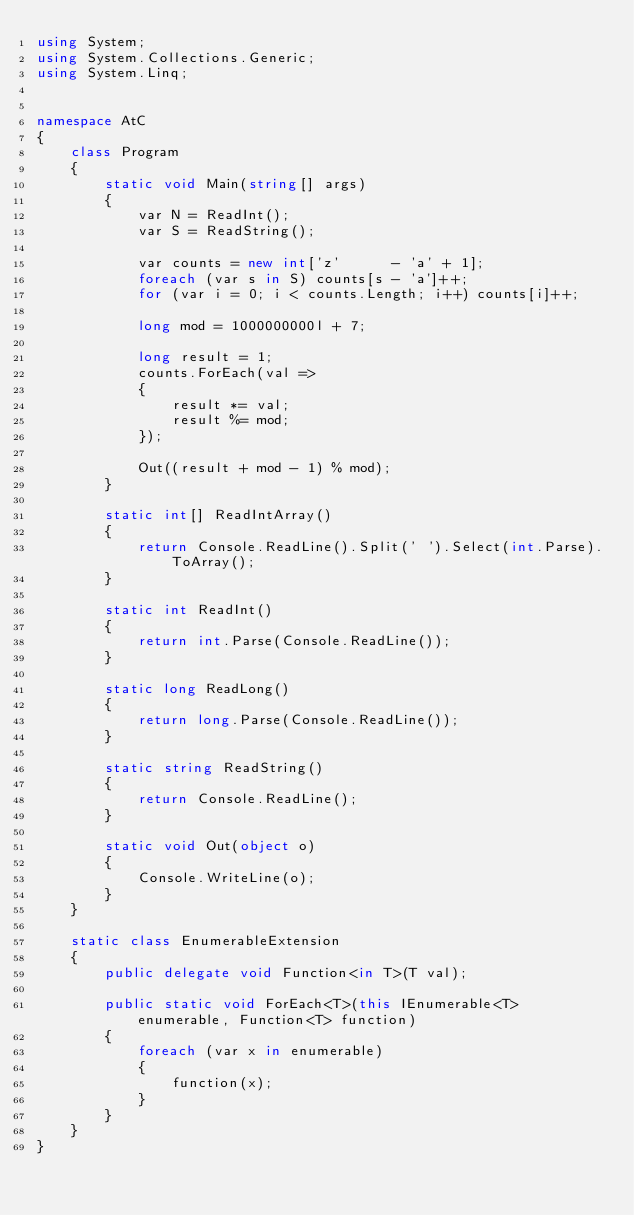<code> <loc_0><loc_0><loc_500><loc_500><_C#_>using System;
using System.Collections.Generic;
using System.Linq;


namespace AtC
{
    class Program
    {
        static void Main(string[] args)
        {
            var N = ReadInt();
            var S = ReadString();

            var counts = new int['z'      - 'a' + 1];
            foreach (var s in S) counts[s - 'a']++;
            for (var i = 0; i < counts.Length; i++) counts[i]++;

            long mod = 1000000000l + 7;

            long result = 1;
            counts.ForEach(val =>
            {
                result *= val;
                result %= mod;
            });

            Out((result + mod - 1) % mod);
        }

        static int[] ReadIntArray()
        {
            return Console.ReadLine().Split(' ').Select(int.Parse).ToArray();
        }

        static int ReadInt()
        {
            return int.Parse(Console.ReadLine());
        }

        static long ReadLong()
        {
            return long.Parse(Console.ReadLine());
        }

        static string ReadString()
        {
            return Console.ReadLine();
        }

        static void Out(object o)
        {
            Console.WriteLine(o);
        }
    }

    static class EnumerableExtension
    {
        public delegate void Function<in T>(T val);

        public static void ForEach<T>(this IEnumerable<T> enumerable, Function<T> function)
        {
            foreach (var x in enumerable)
            {
                function(x);
            }
        }
    }
}</code> 